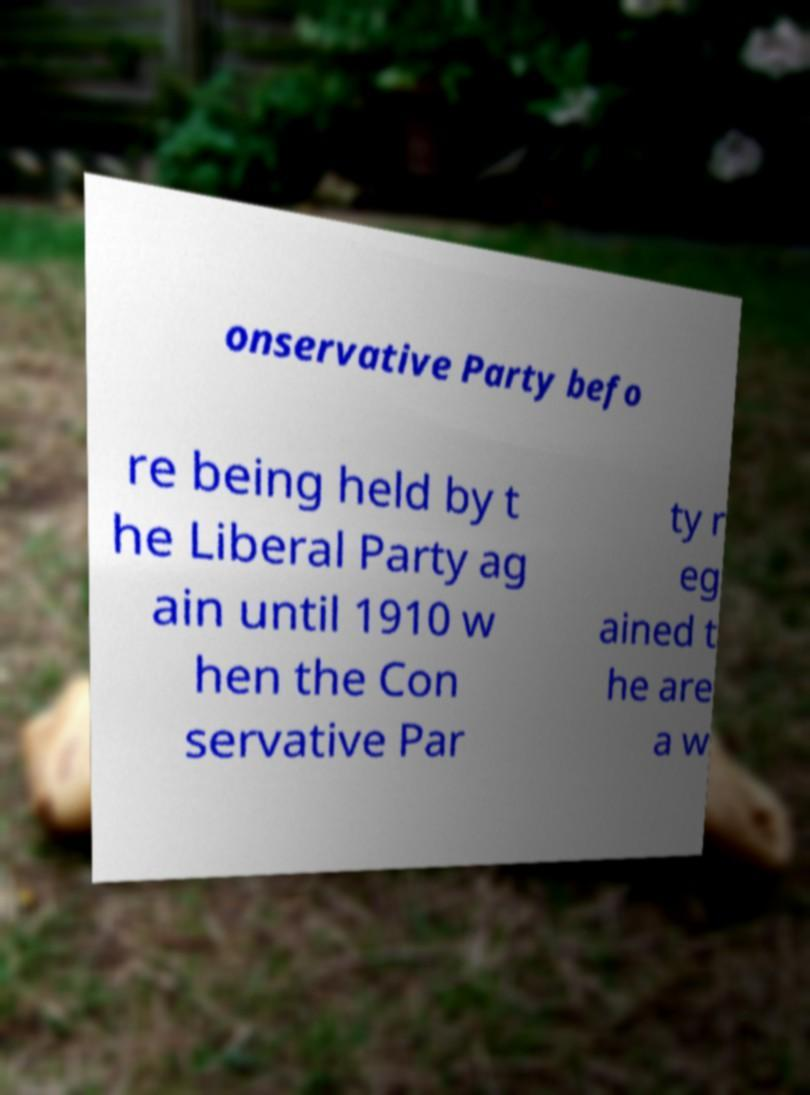There's text embedded in this image that I need extracted. Can you transcribe it verbatim? onservative Party befo re being held by t he Liberal Party ag ain until 1910 w hen the Con servative Par ty r eg ained t he are a w 